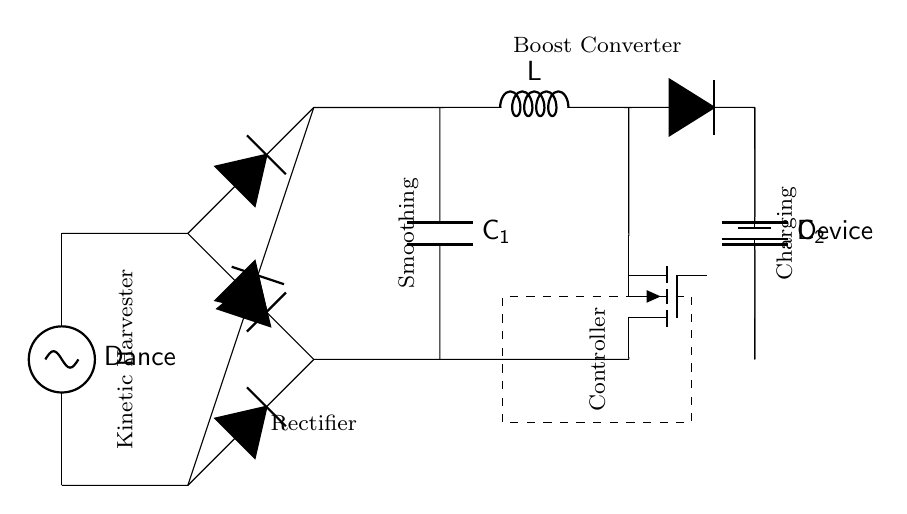What is the main energy source for this circuit? The main energy source is the kinetic energy generated from dance movements, represented by the voltage source labeled "Dance."
Answer: Dance What does the component labeled C1 do? C1, the smoothing capacitor, is used to reduce voltage fluctuations and provide a more stable output voltage to the load.
Answer: Smoothing How many diodes are used in the rectifier bridge? The rectifier bridge consists of four diodes arranged to convert AC to DC, which is essential for charging the device.
Answer: Four What type of converter is used in this circuit? The circuit uses a boost converter, indicated by the labeled component between C1 and the load, which steps up the voltage to the required level for the device.
Answer: Boost converter What is the purpose of the controller in the circuit? The controller manages the operation of the boost converter and ensures efficient charging of the device while protecting it from overcharging.
Answer: Management Where is the device being charged located? The device is connected at the terminal labeled "Device," situated at the end of the circuit where the output voltage is applied.
Answer: End of the circuit What happens to the energy harvested from dance movements? The harvested kinetic energy is converted into electrical energy through the rectifier, smoothed by the capacitor, and boosted to charge the device.
Answer: Converted into electrical energy 